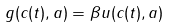Convert formula to latex. <formula><loc_0><loc_0><loc_500><loc_500>g ( c ( t ) , a ) = \beta u ( c ( t ) , a )</formula> 